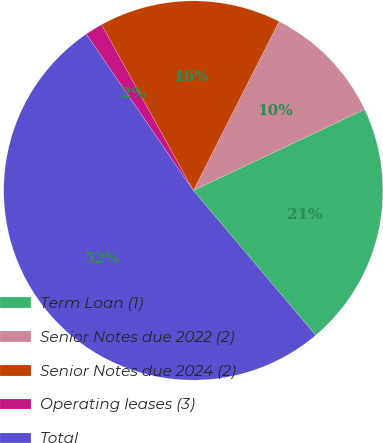<chart> <loc_0><loc_0><loc_500><loc_500><pie_chart><fcel>Term Loan (1)<fcel>Senior Notes due 2022 (2)<fcel>Senior Notes due 2024 (2)<fcel>Operating leases (3)<fcel>Total<nl><fcel>20.87%<fcel>10.5%<fcel>15.51%<fcel>1.51%<fcel>51.62%<nl></chart> 